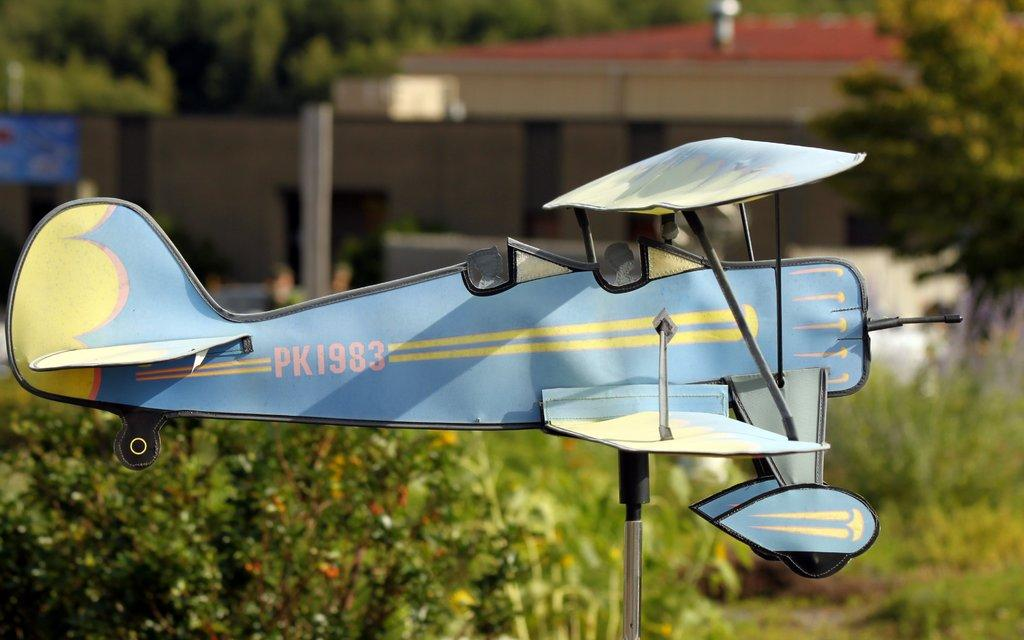<image>
Render a clear and concise summary of the photo. A plane has the marking PK1983 on the side. 